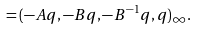<formula> <loc_0><loc_0><loc_500><loc_500>= ( - A q , - B q , - B ^ { - 1 } q , q ) _ { \infty } .</formula> 